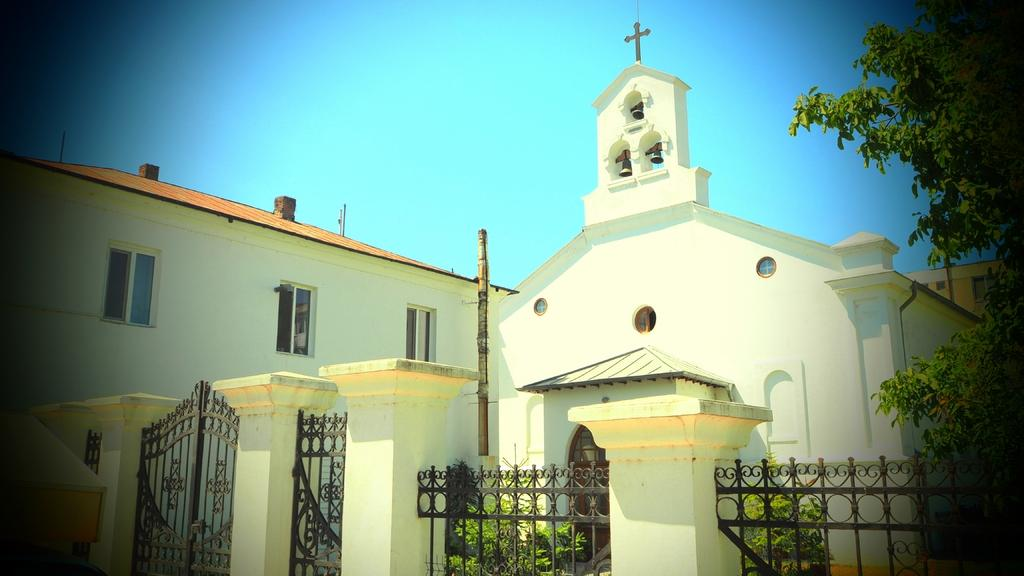What is the color of the building in the image? The building in the image is white-colored. What feature can be seen on the building? The building has windows. What type of entrance is present in the image? There are iron gates in the image. What type of vegetation is present in the image? Plants and a tree are present in the image. What can be seen in the background of the image? The sky is visible in the background of the image. What type of beverage is visible in the image? There are beers visible in the image. What type of desk is visible in the image? There is no desk present in the image. What is the desire of the plants in the image? Plants do not have desires, so this question cannot be answered. 